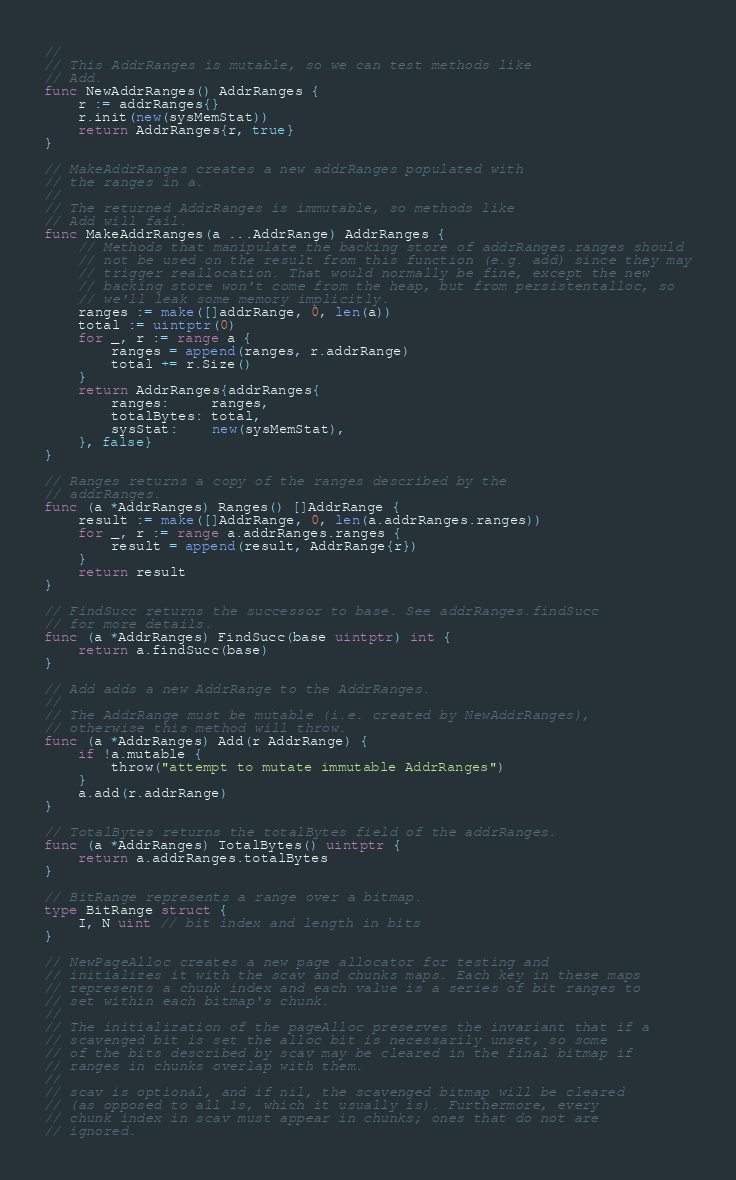<code> <loc_0><loc_0><loc_500><loc_500><_Go_>//
// This AddrRanges is mutable, so we can test methods like
// Add.
func NewAddrRanges() AddrRanges {
	r := addrRanges{}
	r.init(new(sysMemStat))
	return AddrRanges{r, true}
}

// MakeAddrRanges creates a new addrRanges populated with
// the ranges in a.
//
// The returned AddrRanges is immutable, so methods like
// Add will fail.
func MakeAddrRanges(a ...AddrRange) AddrRanges {
	// Methods that manipulate the backing store of addrRanges.ranges should
	// not be used on the result from this function (e.g. add) since they may
	// trigger reallocation. That would normally be fine, except the new
	// backing store won't come from the heap, but from persistentalloc, so
	// we'll leak some memory implicitly.
	ranges := make([]addrRange, 0, len(a))
	total := uintptr(0)
	for _, r := range a {
		ranges = append(ranges, r.addrRange)
		total += r.Size()
	}
	return AddrRanges{addrRanges{
		ranges:     ranges,
		totalBytes: total,
		sysStat:    new(sysMemStat),
	}, false}
}

// Ranges returns a copy of the ranges described by the
// addrRanges.
func (a *AddrRanges) Ranges() []AddrRange {
	result := make([]AddrRange, 0, len(a.addrRanges.ranges))
	for _, r := range a.addrRanges.ranges {
		result = append(result, AddrRange{r})
	}
	return result
}

// FindSucc returns the successor to base. See addrRanges.findSucc
// for more details.
func (a *AddrRanges) FindSucc(base uintptr) int {
	return a.findSucc(base)
}

// Add adds a new AddrRange to the AddrRanges.
//
// The AddrRange must be mutable (i.e. created by NewAddrRanges),
// otherwise this method will throw.
func (a *AddrRanges) Add(r AddrRange) {
	if !a.mutable {
		throw("attempt to mutate immutable AddrRanges")
	}
	a.add(r.addrRange)
}

// TotalBytes returns the totalBytes field of the addrRanges.
func (a *AddrRanges) TotalBytes() uintptr {
	return a.addrRanges.totalBytes
}

// BitRange represents a range over a bitmap.
type BitRange struct {
	I, N uint // bit index and length in bits
}

// NewPageAlloc creates a new page allocator for testing and
// initializes it with the scav and chunks maps. Each key in these maps
// represents a chunk index and each value is a series of bit ranges to
// set within each bitmap's chunk.
//
// The initialization of the pageAlloc preserves the invariant that if a
// scavenged bit is set the alloc bit is necessarily unset, so some
// of the bits described by scav may be cleared in the final bitmap if
// ranges in chunks overlap with them.
//
// scav is optional, and if nil, the scavenged bitmap will be cleared
// (as opposed to all 1s, which it usually is). Furthermore, every
// chunk index in scav must appear in chunks; ones that do not are
// ignored.</code> 